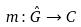<formula> <loc_0><loc_0><loc_500><loc_500>m \colon \hat { G } \rightarrow C</formula> 